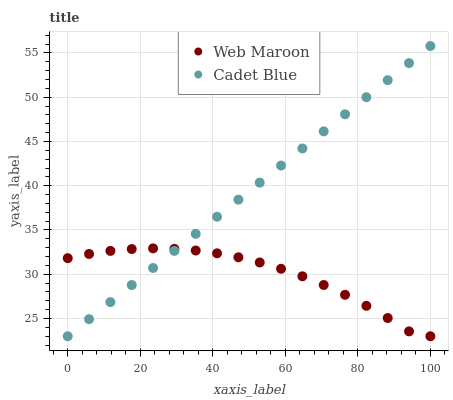Does Web Maroon have the minimum area under the curve?
Answer yes or no. Yes. Does Cadet Blue have the maximum area under the curve?
Answer yes or no. Yes. Does Web Maroon have the maximum area under the curve?
Answer yes or no. No. Is Cadet Blue the smoothest?
Answer yes or no. Yes. Is Web Maroon the roughest?
Answer yes or no. Yes. Is Web Maroon the smoothest?
Answer yes or no. No. Does Cadet Blue have the lowest value?
Answer yes or no. Yes. Does Cadet Blue have the highest value?
Answer yes or no. Yes. Does Web Maroon have the highest value?
Answer yes or no. No. Does Web Maroon intersect Cadet Blue?
Answer yes or no. Yes. Is Web Maroon less than Cadet Blue?
Answer yes or no. No. Is Web Maroon greater than Cadet Blue?
Answer yes or no. No. 